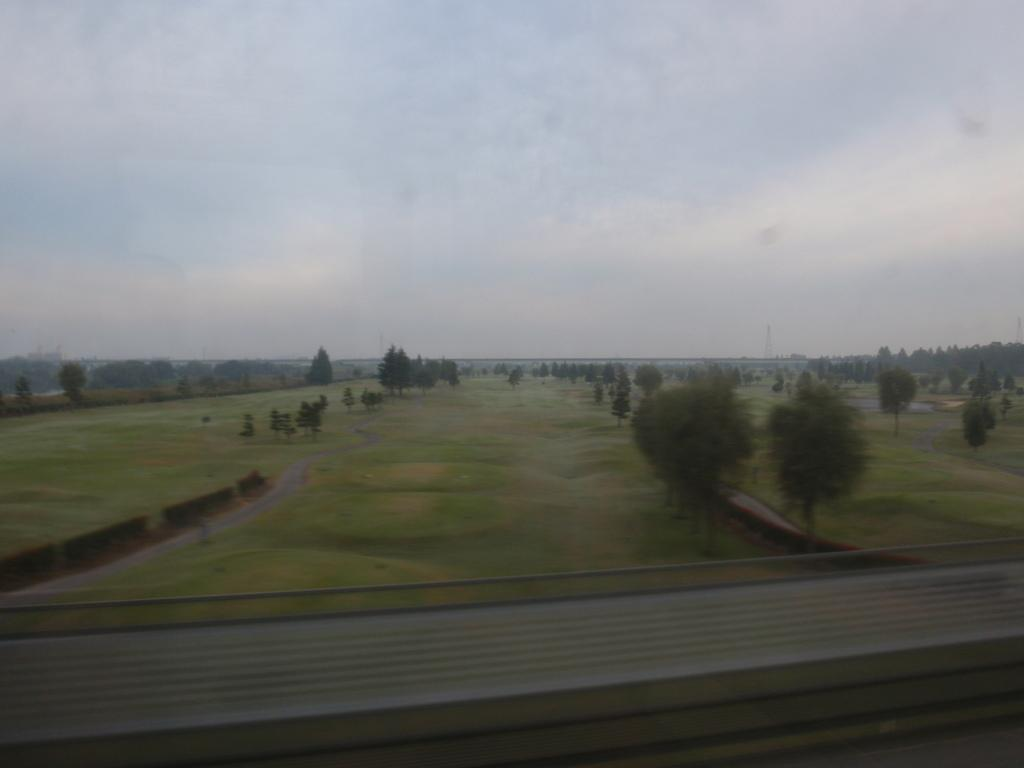What type of surface is visible in the image? The image shows ground. What type of vegetation can be seen in the image? There are trees in the image. What part of the natural environment is visible in the background of the image? The sky is visible in the background of the image. What type of rail can be seen in the image? There is no rail present in the image. How does the stomach of the tree appear in the image? Trees do not have stomachs, as they are plants and not animals. 